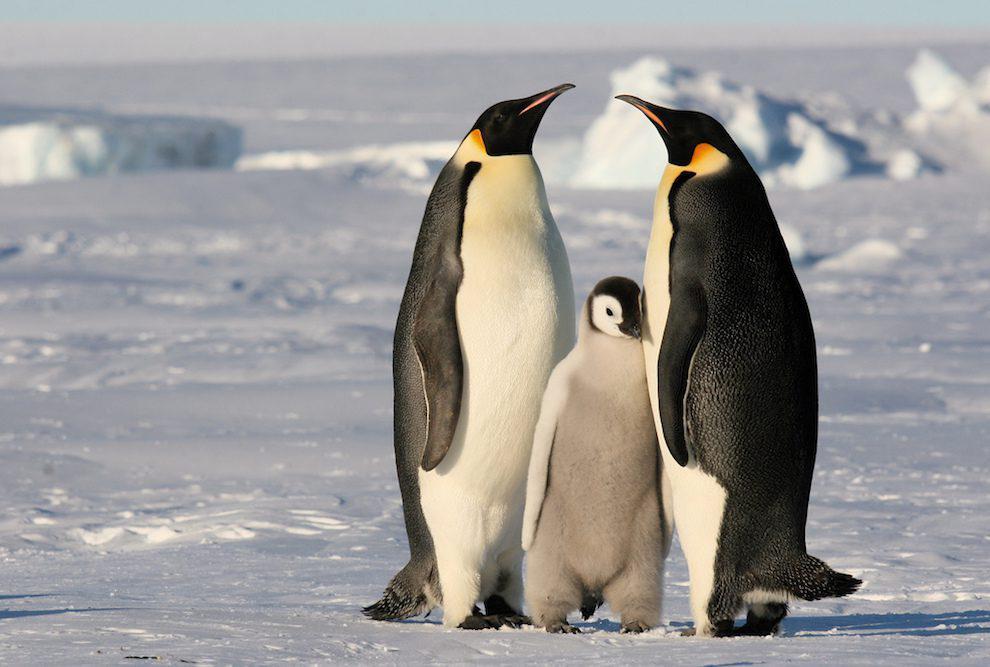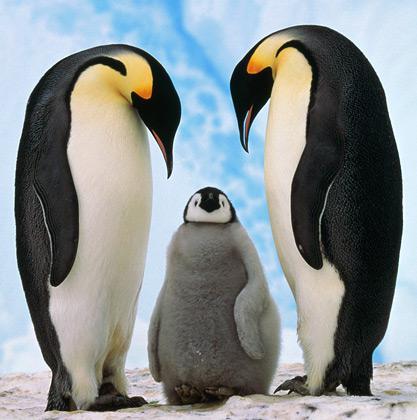The first image is the image on the left, the second image is the image on the right. Examine the images to the left and right. Is the description "A penguin in the foreground is at least partly covered in brown fuzzy feathers." accurate? Answer yes or no. No. The first image is the image on the left, the second image is the image on the right. For the images displayed, is the sentence "There are exactly three animals in the image on the right." factually correct? Answer yes or no. Yes. 